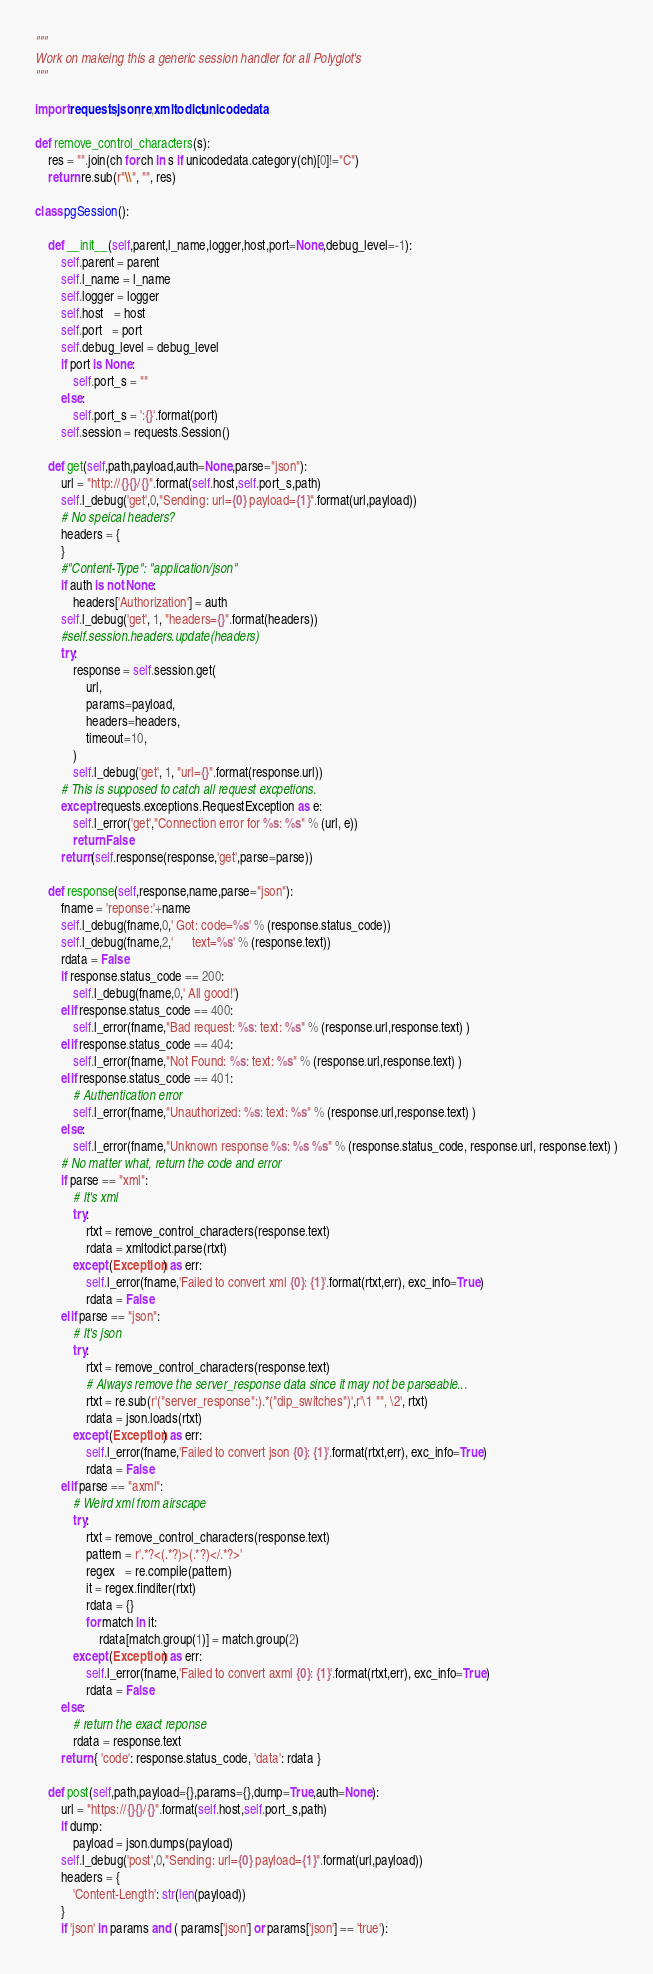<code> <loc_0><loc_0><loc_500><loc_500><_Python_>"""
Work on makeing this a generic session handler for all Polyglot's
"""

import requests,json,re,xmltodict,unicodedata

def remove_control_characters(s):
    res = "".join(ch for ch in s if unicodedata.category(ch)[0]!="C")
    return re.sub(r"\\", "", res)

class pgSession():

    def __init__(self,parent,l_name,logger,host,port=None,debug_level=-1):
        self.parent = parent
        self.l_name = l_name
        self.logger = logger
        self.host   = host
        self.port   = port
        self.debug_level = debug_level
        if port is None:
            self.port_s = ""
        else:
            self.port_s = ':{}'.format(port)
        self.session = requests.Session()

    def get(self,path,payload,auth=None,parse="json"):
        url = "http://{}{}/{}".format(self.host,self.port_s,path)
        self.l_debug('get',0,"Sending: url={0} payload={1}".format(url,payload))
        # No speical headers?
        headers = {
        }
        #"Content-Type": "application/json"
        if auth is not None:
            headers['Authorization'] = auth
        self.l_debug('get', 1, "headers={}".format(headers))
        #self.session.headers.update(headers)
        try:
            response = self.session.get(
                url,
                params=payload,
                headers=headers,
                timeout=10,
            )
            self.l_debug('get', 1, "url={}".format(response.url))
        # This is supposed to catch all request excpetions.
        except requests.exceptions.RequestException as e:
            self.l_error('get',"Connection error for %s: %s" % (url, e))
            return False
        return(self.response(response,'get',parse=parse))

    def response(self,response,name,parse="json"):
        fname = 'reponse:'+name
        self.l_debug(fname,0,' Got: code=%s' % (response.status_code))
        self.l_debug(fname,2,'      text=%s' % (response.text))
        rdata = False
        if response.status_code == 200:
            self.l_debug(fname,0,' All good!')
        elif response.status_code == 400:
            self.l_error(fname,"Bad request: %s: text: %s" % (response.url,response.text) )
        elif response.status_code == 404:
            self.l_error(fname,"Not Found: %s: text: %s" % (response.url,response.text) )
        elif response.status_code == 401:
            # Authentication error
            self.l_error(fname,"Unauthorized: %s: text: %s" % (response.url,response.text) )
        else:
            self.l_error(fname,"Unknown response %s: %s %s" % (response.status_code, response.url, response.text) )
        # No matter what, return the code and error
        if parse == "xml":
            # It's xml
            try:
                rtxt = remove_control_characters(response.text)
                rdata = xmltodict.parse(rtxt)
            except (Exception) as err:
                self.l_error(fname,'Failed to convert xml {0}: {1}'.format(rtxt,err), exc_info=True)
                rdata = False
        elif parse == "json":
            # It's json
            try:
                rtxt = remove_control_characters(response.text)
                # Always remove the server_response data since it may not be parseable...
                rtxt = re.sub(r'("server_response":).*("dip_switches")',r'\1 "", \2', rtxt)
                rdata = json.loads(rtxt)
            except (Exception) as err:
                self.l_error(fname,'Failed to convert json {0}: {1}'.format(rtxt,err), exc_info=True)
                rdata = False
        elif parse == "axml":
            # Weird xml from airscape
            try:
                rtxt = remove_control_characters(response.text)
                pattern = r'.*?<(.*?)>(.*?)</.*?>'
                regex   = re.compile(pattern)
                it = regex.finditer(rtxt)
                rdata = {}
                for match in it:
                    rdata[match.group(1)] = match.group(2)
            except (Exception) as err:
                self.l_error(fname,'Failed to convert axml {0}: {1}'.format(rtxt,err), exc_info=True)
                rdata = False
        else:
            # return the exact reponse
            rdata = response.text
        return { 'code': response.status_code, 'data': rdata }

    def post(self,path,payload={},params={},dump=True,auth=None):
        url = "https://{}{}/{}".format(self.host,self.port_s,path)
        if dump:
            payload = json.dumps(payload)
        self.l_debug('post',0,"Sending: url={0} payload={1}".format(url,payload))
        headers = {
            'Content-Length': str(len(payload))
        }
        if 'json' in params and ( params['json'] or params['json'] == 'true'):</code> 